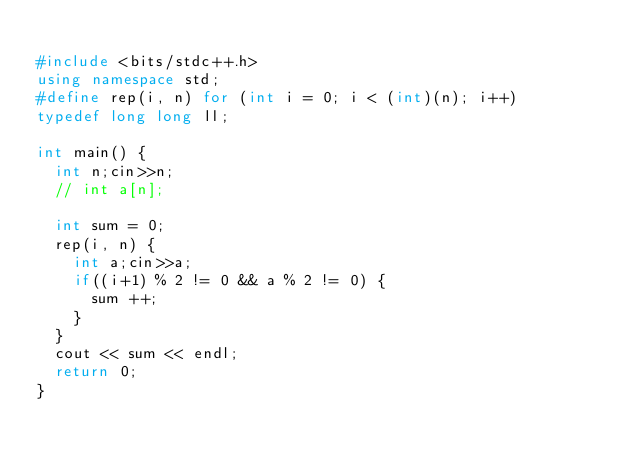Convert code to text. <code><loc_0><loc_0><loc_500><loc_500><_C++_>
#include <bits/stdc++.h>
using namespace std;
#define rep(i, n) for (int i = 0; i < (int)(n); i++)
typedef long long ll;

int main() {
  int n;cin>>n;
  // int a[n];

  int sum = 0;
  rep(i, n) {
    int a;cin>>a;
    if((i+1) % 2 != 0 && a % 2 != 0) {
      sum ++;
    }
  }
  cout << sum << endl;
  return 0;
}
</code> 